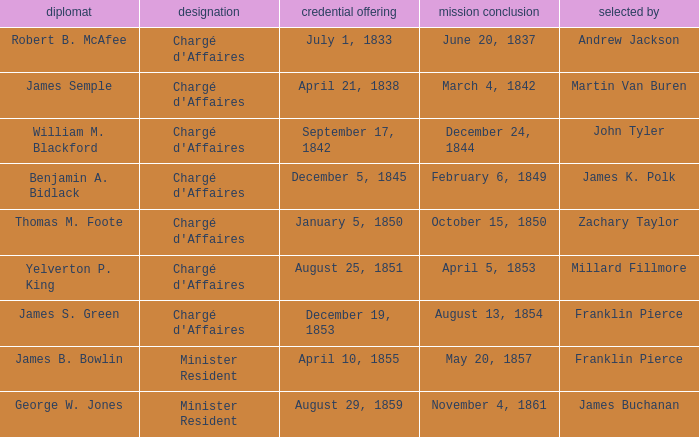What Title has a Termination of Mission of November 4, 1861? Minister Resident. 